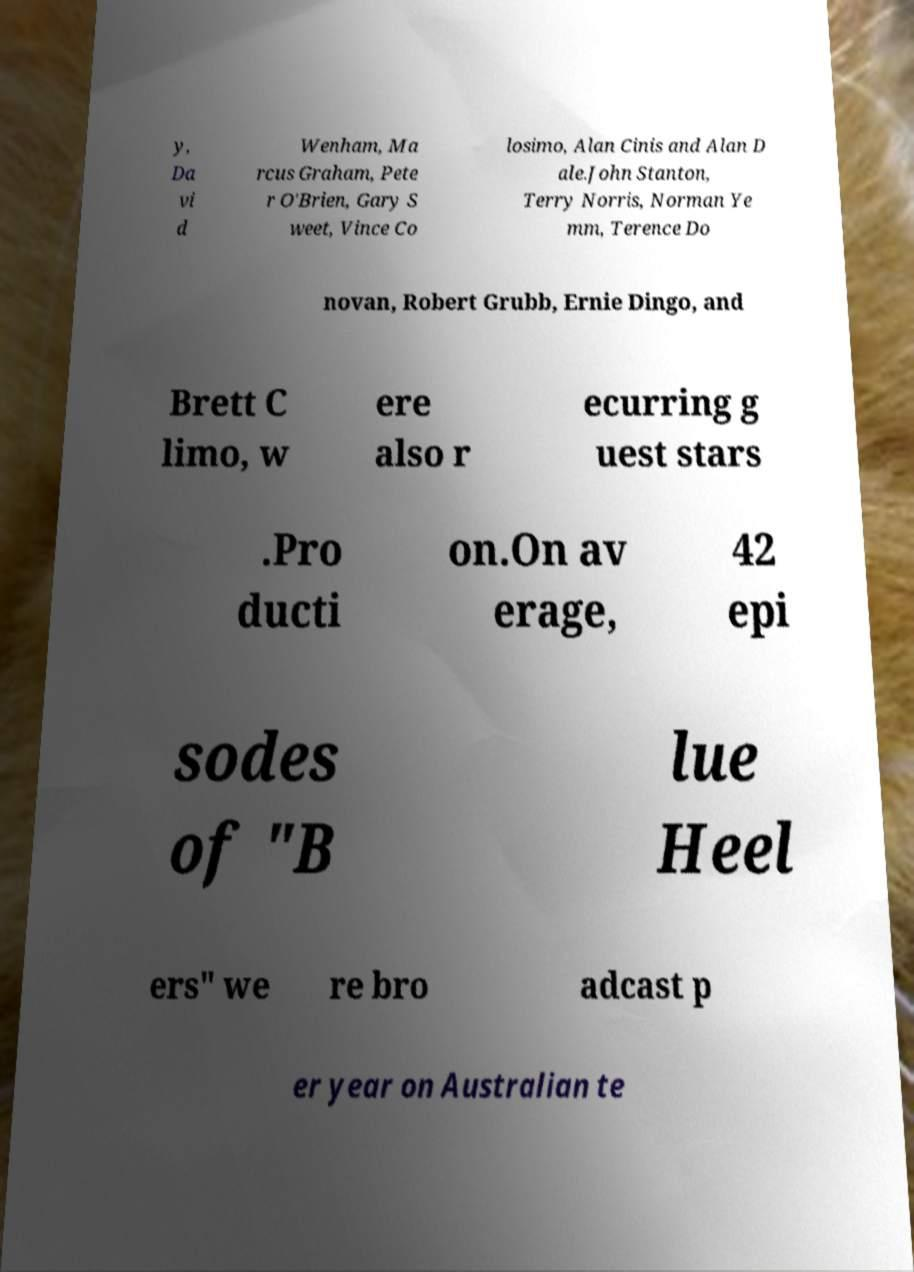There's text embedded in this image that I need extracted. Can you transcribe it verbatim? y, Da vi d Wenham, Ma rcus Graham, Pete r O'Brien, Gary S weet, Vince Co losimo, Alan Cinis and Alan D ale.John Stanton, Terry Norris, Norman Ye mm, Terence Do novan, Robert Grubb, Ernie Dingo, and Brett C limo, w ere also r ecurring g uest stars .Pro ducti on.On av erage, 42 epi sodes of "B lue Heel ers" we re bro adcast p er year on Australian te 